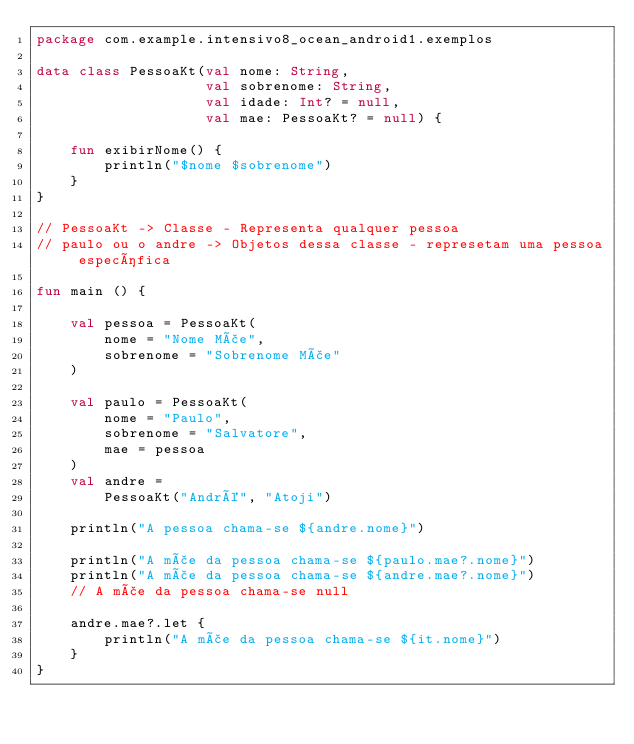Convert code to text. <code><loc_0><loc_0><loc_500><loc_500><_Kotlin_>package com.example.intensivo8_ocean_android1.exemplos

data class PessoaKt(val nome: String,
                    val sobrenome: String,
                    val idade: Int? = null,
                    val mae: PessoaKt? = null) {

    fun exibirNome() {
        println("$nome $sobrenome")
    }
}

// PessoaKt -> Classe - Representa qualquer pessoa
// paulo ou o andre -> Objetos dessa classe - represetam uma pessoa específica

fun main () {

    val pessoa = PessoaKt(
        nome = "Nome Mãe",
        sobrenome = "Sobrenome Mãe"
    )

    val paulo = PessoaKt(
        nome = "Paulo",
        sobrenome = "Salvatore",
        mae = pessoa
    )
    val andre =
        PessoaKt("André", "Atoji")

    println("A pessoa chama-se ${andre.nome}")

    println("A mãe da pessoa chama-se ${paulo.mae?.nome}")
    println("A mãe da pessoa chama-se ${andre.mae?.nome}")
    // A mãe da pessoa chama-se null

    andre.mae?.let {
        println("A mãe da pessoa chama-se ${it.nome}")
    }
}
</code> 